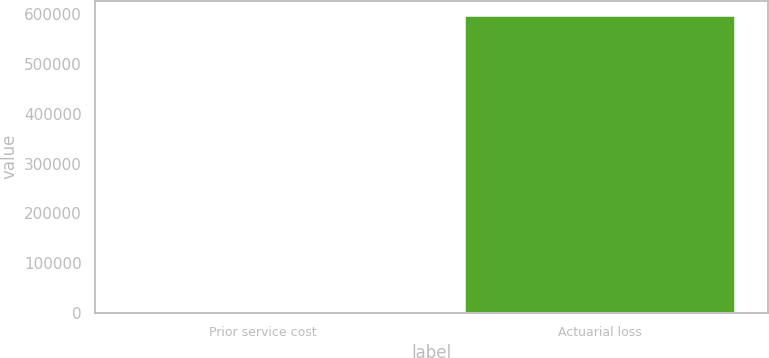<chart> <loc_0><loc_0><loc_500><loc_500><bar_chart><fcel>Prior service cost<fcel>Actuarial loss<nl><fcel>157<fcel>597614<nl></chart> 